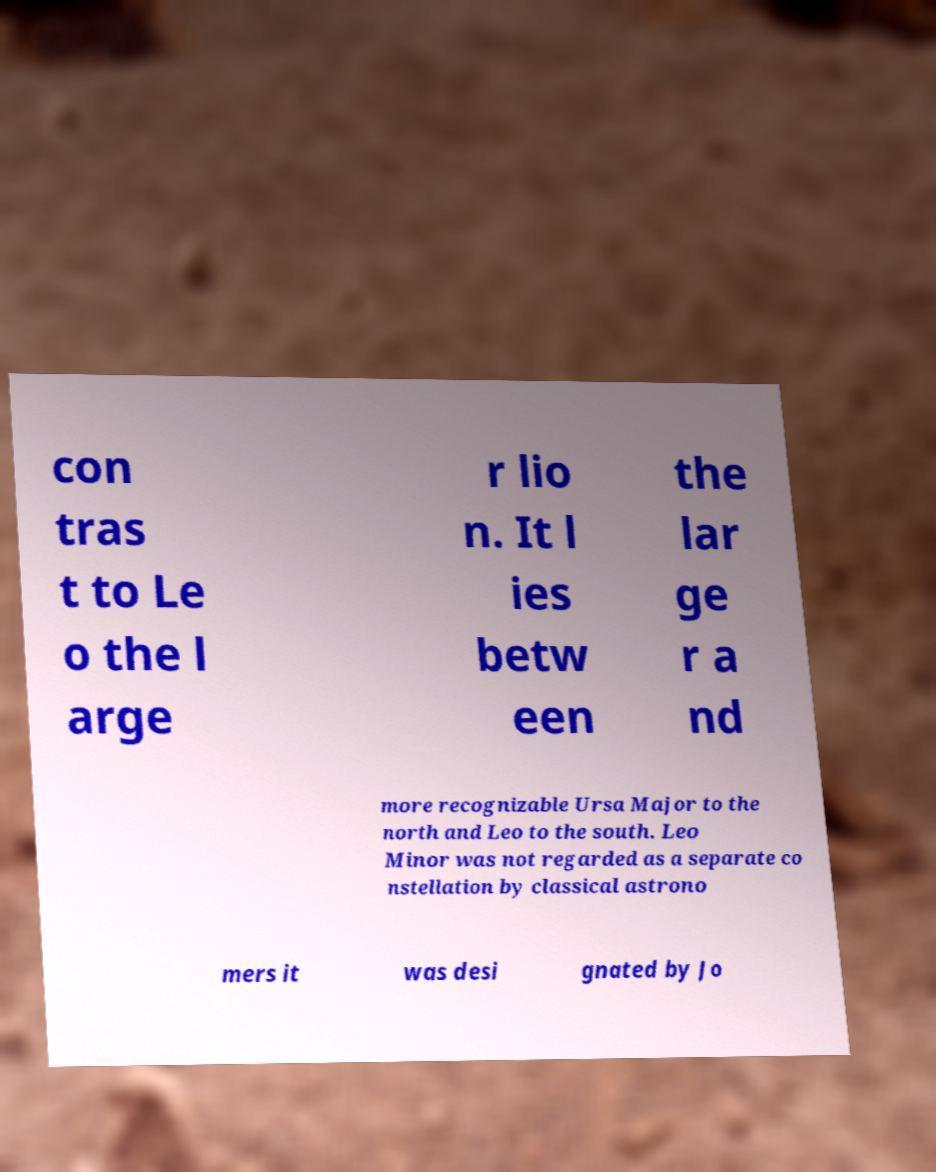Could you extract and type out the text from this image? con tras t to Le o the l arge r lio n. It l ies betw een the lar ge r a nd more recognizable Ursa Major to the north and Leo to the south. Leo Minor was not regarded as a separate co nstellation by classical astrono mers it was desi gnated by Jo 